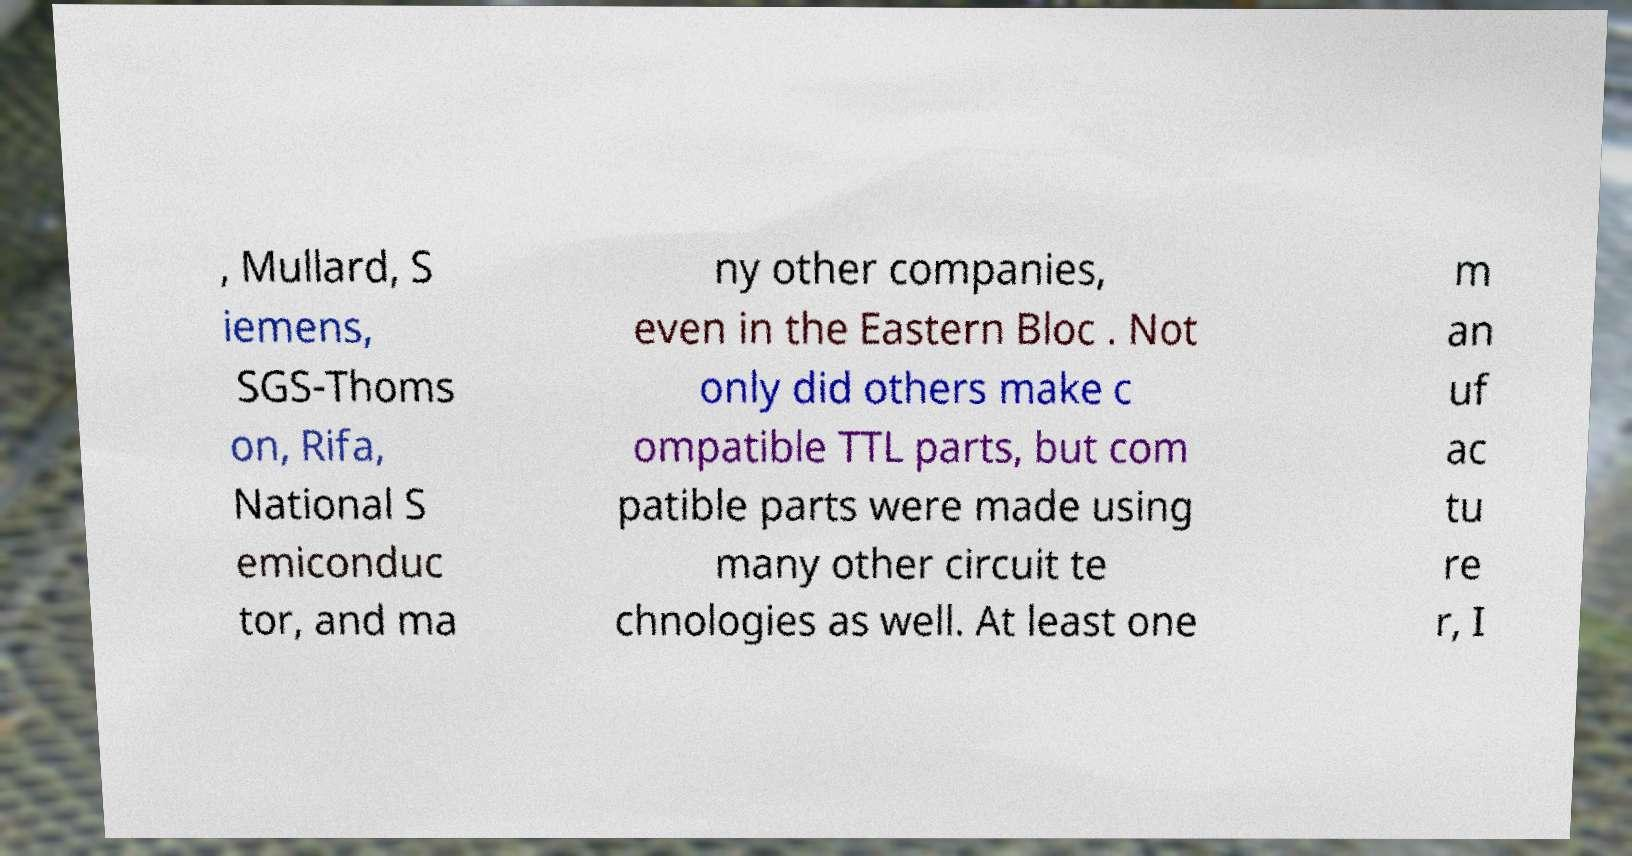I need the written content from this picture converted into text. Can you do that? , Mullard, S iemens, SGS-Thoms on, Rifa, National S emiconduc tor, and ma ny other companies, even in the Eastern Bloc . Not only did others make c ompatible TTL parts, but com patible parts were made using many other circuit te chnologies as well. At least one m an uf ac tu re r, I 